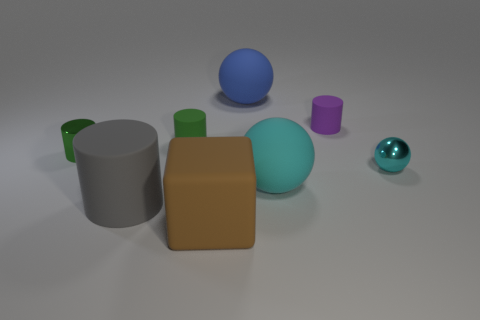Could you describe the mood or atmosphere this image might evoke? The image has a controlled, serene atmosphere. With its soft lighting, gentle shadows, and a palette of calming colors, it evokes a sense of tranquility and simplicity. The cleanliness and order of the scene contribute to a peaceful vibe. 